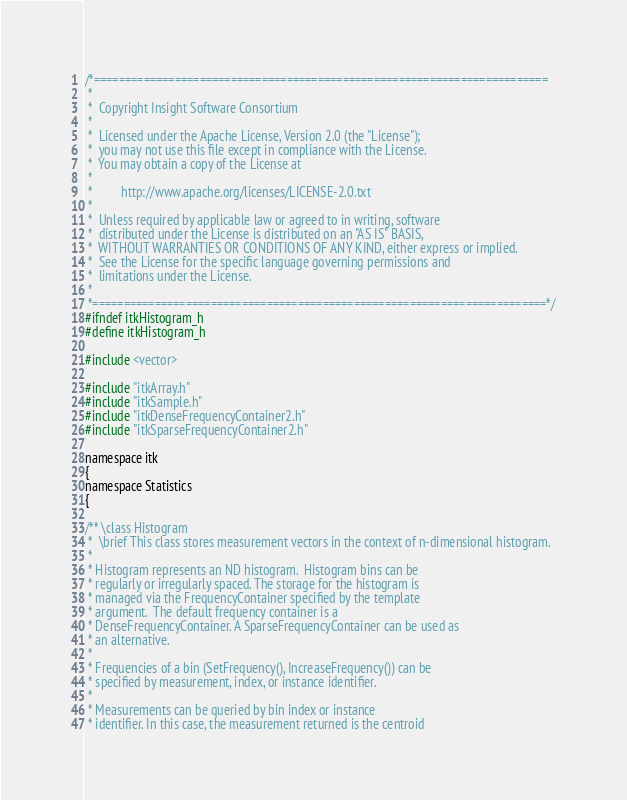Convert code to text. <code><loc_0><loc_0><loc_500><loc_500><_C_>/*=========================================================================
 *
 *  Copyright Insight Software Consortium
 *
 *  Licensed under the Apache License, Version 2.0 (the "License");
 *  you may not use this file except in compliance with the License.
 *  You may obtain a copy of the License at
 *
 *         http://www.apache.org/licenses/LICENSE-2.0.txt
 *
 *  Unless required by applicable law or agreed to in writing, software
 *  distributed under the License is distributed on an "AS IS" BASIS,
 *  WITHOUT WARRANTIES OR CONDITIONS OF ANY KIND, either express or implied.
 *  See the License for the specific language governing permissions and
 *  limitations under the License.
 *
 *=========================================================================*/
#ifndef itkHistogram_h
#define itkHistogram_h

#include <vector>

#include "itkArray.h"
#include "itkSample.h"
#include "itkDenseFrequencyContainer2.h"
#include "itkSparseFrequencyContainer2.h"

namespace itk
{
namespace Statistics
{

/** \class Histogram
 *  \brief This class stores measurement vectors in the context of n-dimensional histogram.
 *
 * Histogram represents an ND histogram.  Histogram bins can be
 * regularly or irregularly spaced. The storage for the histogram is
 * managed via the FrequencyContainer specified by the template
 * argument.  The default frequency container is a
 * DenseFrequencyContainer. A SparseFrequencyContainer can be used as
 * an alternative.
 *
 * Frequencies of a bin (SetFrequency(), IncreaseFrequency()) can be
 * specified by measurement, index, or instance identifier.
 *
 * Measurements can be queried by bin index or instance
 * identifier. In this case, the measurement returned is the centroid</code> 